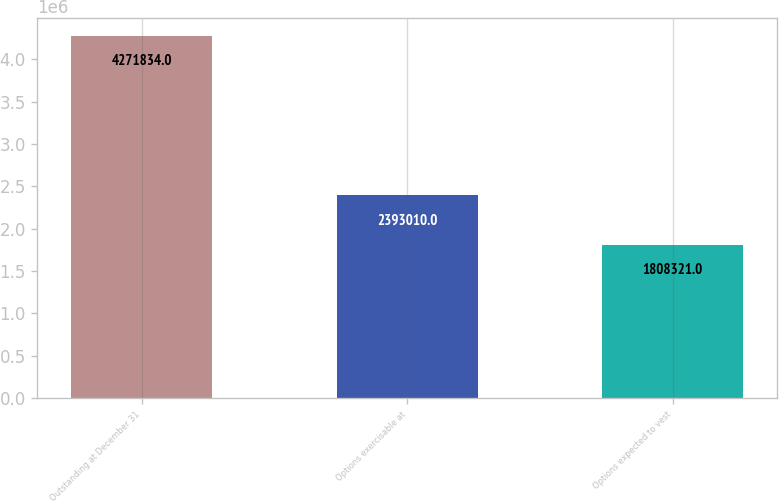Convert chart. <chart><loc_0><loc_0><loc_500><loc_500><bar_chart><fcel>Outstanding at December 31<fcel>Options exercisable at<fcel>Options expected to vest<nl><fcel>4.27183e+06<fcel>2.39301e+06<fcel>1.80832e+06<nl></chart> 